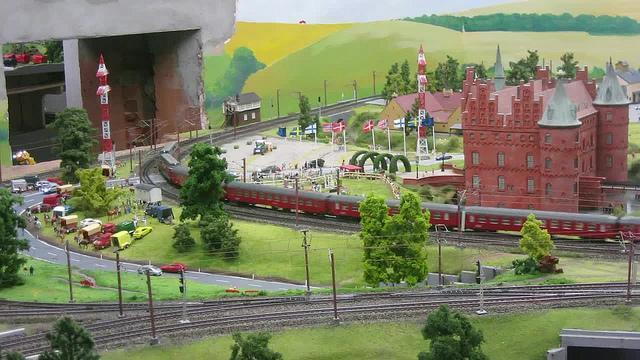Why does the background seem so flat and odd what type train scene does this signify that this is?
Select the accurate answer and provide justification: `Answer: choice
Rationale: srationale.`
Options: Current, new train, old, model train. Answer: model train.
Rationale: The background is not real, it is printed on a board to set the scene for the visual appeal of the model train. 